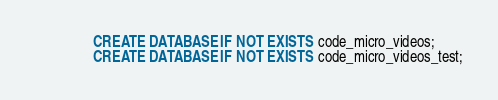Convert code to text. <code><loc_0><loc_0><loc_500><loc_500><_SQL_>                CREATE DATABASE IF NOT EXISTS code_micro_videos;
                CREATE DATABASE IF NOT EXISTS code_micro_videos_test;
</code> 